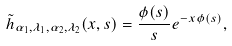<formula> <loc_0><loc_0><loc_500><loc_500>\tilde { h } _ { \alpha _ { 1 } , \lambda _ { 1 } , \alpha _ { 2 } , \lambda _ { 2 } } ( x , s ) = \frac { \phi ( s ) } { s } e ^ { - x \phi ( s ) } ,</formula> 